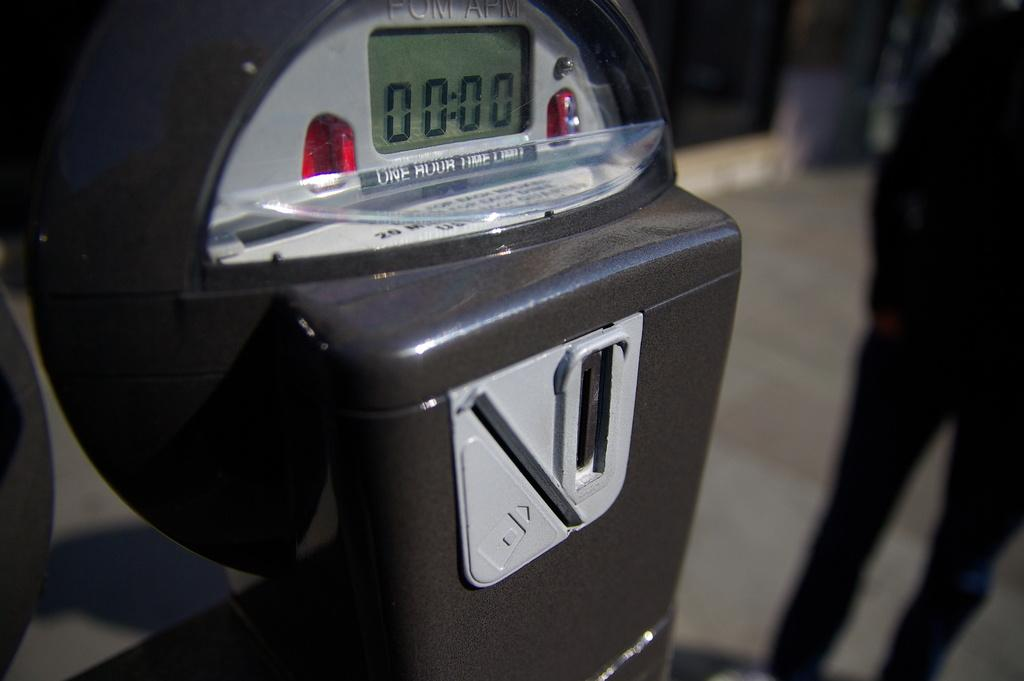<image>
Present a compact description of the photo's key features. A parking meter which has a one hour time limit is out of minutes. 